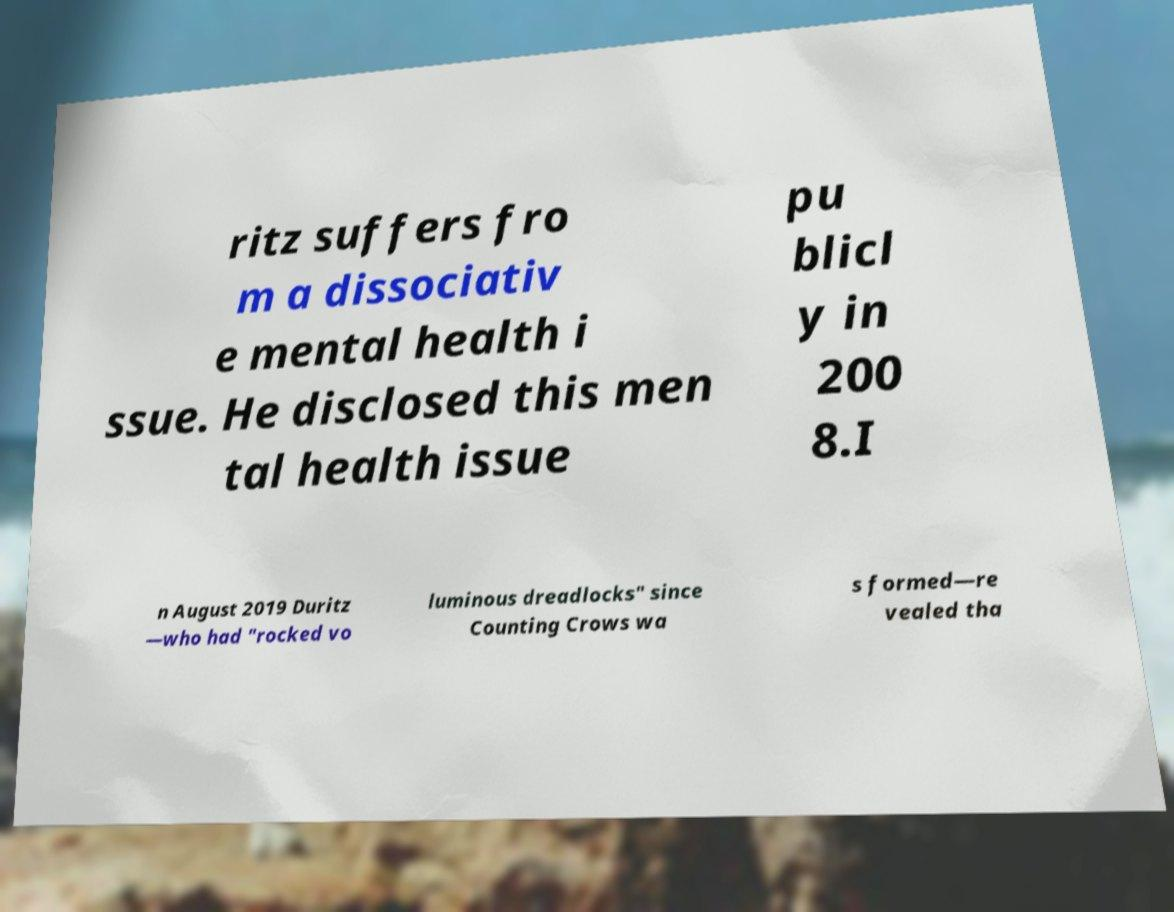Can you read and provide the text displayed in the image?This photo seems to have some interesting text. Can you extract and type it out for me? ritz suffers fro m a dissociativ e mental health i ssue. He disclosed this men tal health issue pu blicl y in 200 8.I n August 2019 Duritz —who had "rocked vo luminous dreadlocks" since Counting Crows wa s formed—re vealed tha 